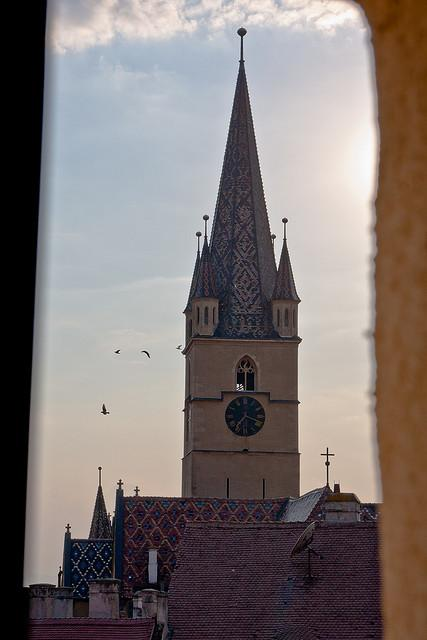How many towers are on the top of the clock tower with a black clock face?

Choices:
A) four
B) two
C) three
D) five five 